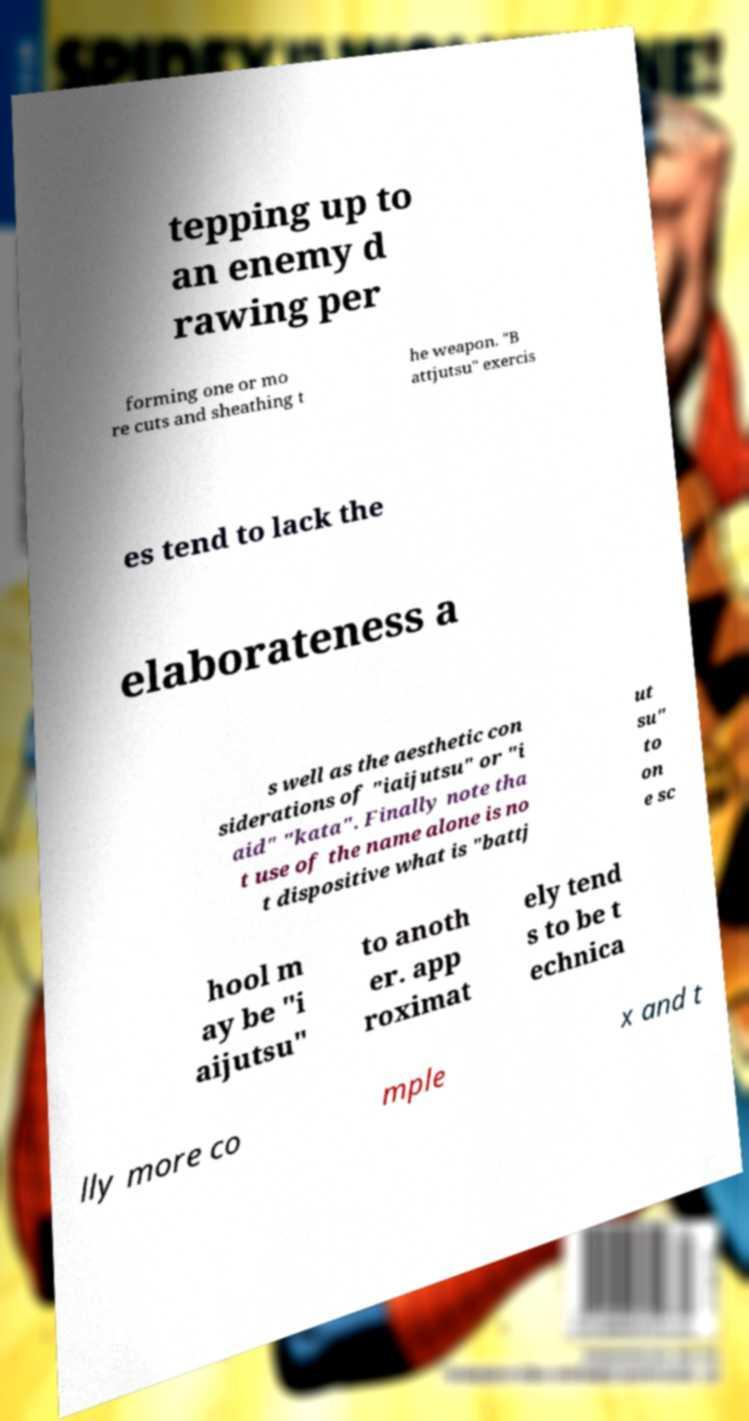I need the written content from this picture converted into text. Can you do that? tepping up to an enemy d rawing per forming one or mo re cuts and sheathing t he weapon. "B attjutsu" exercis es tend to lack the elaborateness a s well as the aesthetic con siderations of "iaijutsu" or "i aid" "kata". Finally note tha t use of the name alone is no t dispositive what is "battj ut su" to on e sc hool m ay be "i aijutsu" to anoth er. app roximat ely tend s to be t echnica lly more co mple x and t 